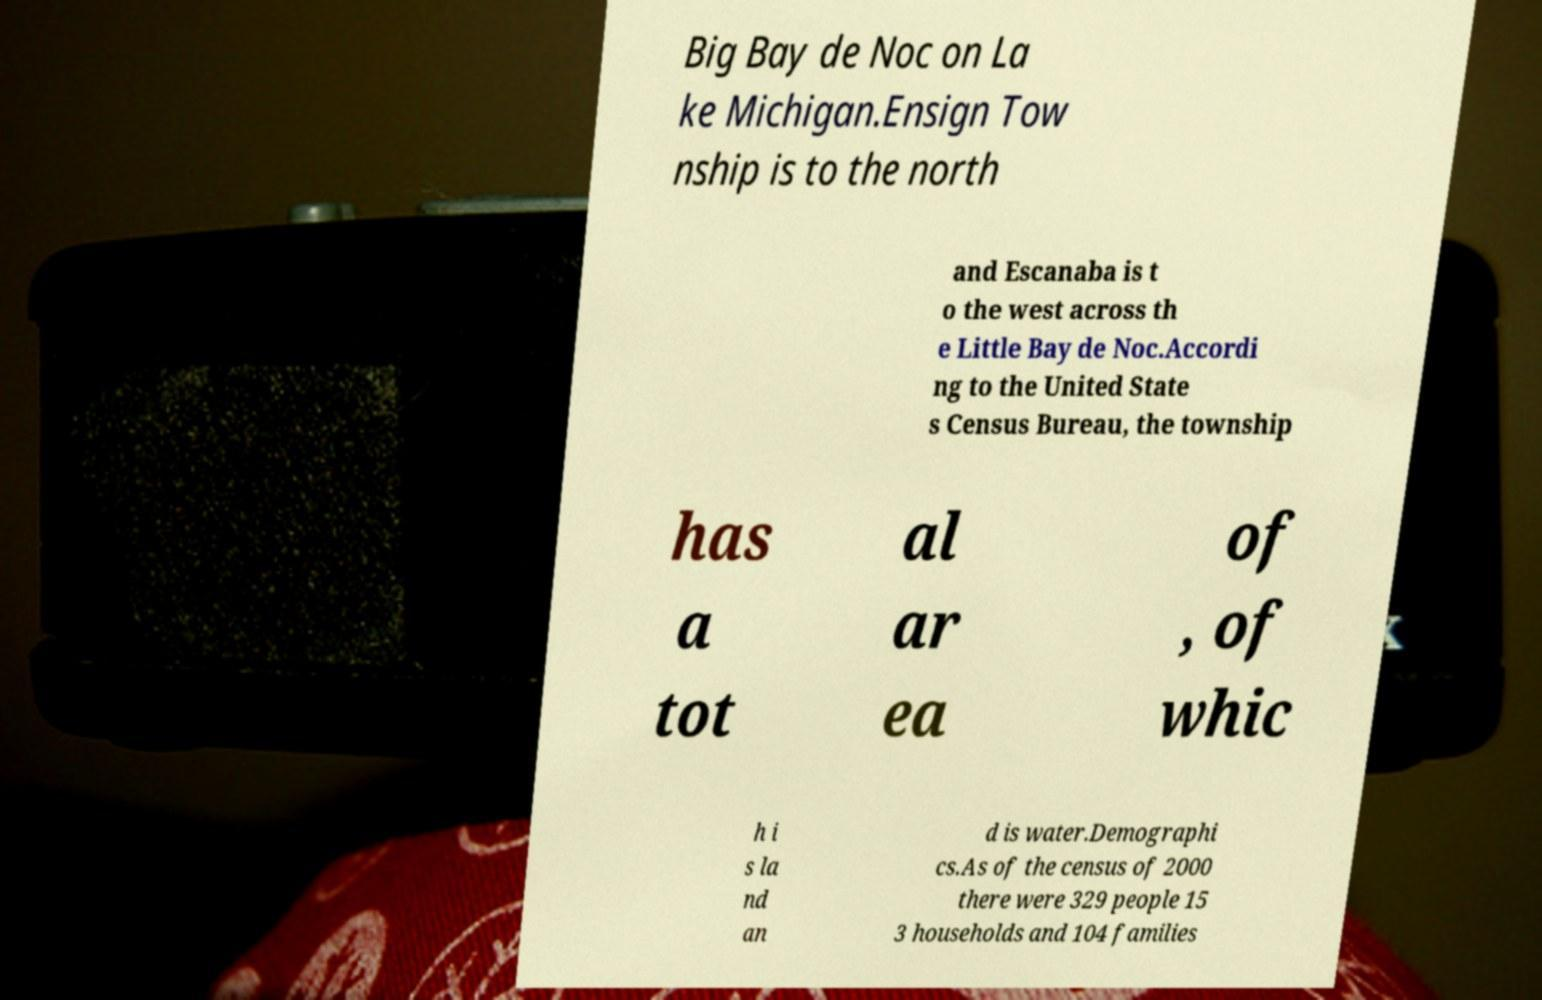There's text embedded in this image that I need extracted. Can you transcribe it verbatim? Big Bay de Noc on La ke Michigan.Ensign Tow nship is to the north and Escanaba is t o the west across th e Little Bay de Noc.Accordi ng to the United State s Census Bureau, the township has a tot al ar ea of , of whic h i s la nd an d is water.Demographi cs.As of the census of 2000 there were 329 people 15 3 households and 104 families 